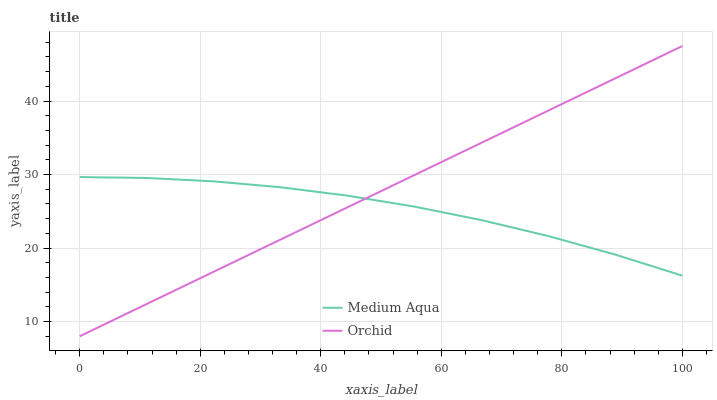Does Orchid have the minimum area under the curve?
Answer yes or no. No. Is Orchid the roughest?
Answer yes or no. No. 